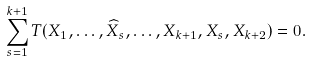Convert formula to latex. <formula><loc_0><loc_0><loc_500><loc_500>\sum _ { s = 1 } ^ { k + 1 } T ( X _ { 1 } , \dots , \widehat { X } _ { s } , \dots , X _ { k + 1 } , X _ { s } , X _ { k + 2 } ) = 0 .</formula> 